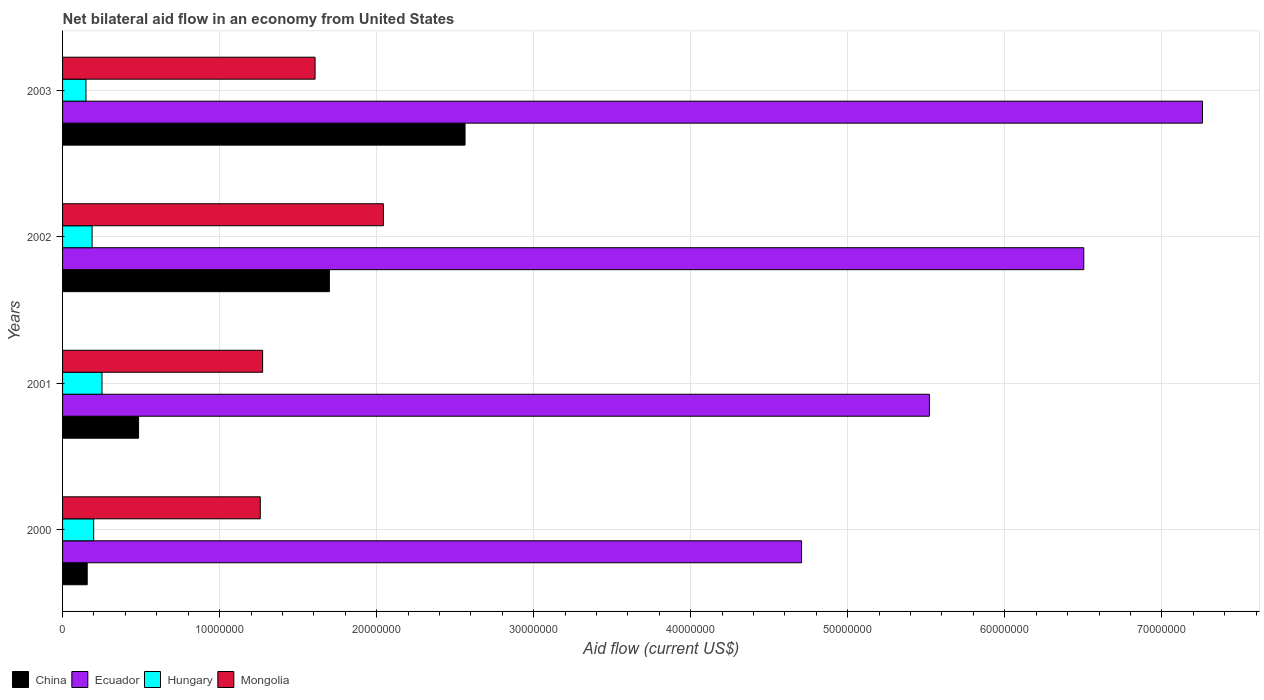How many groups of bars are there?
Make the answer very short. 4. Are the number of bars on each tick of the Y-axis equal?
Your response must be concise. Yes. How many bars are there on the 3rd tick from the top?
Ensure brevity in your answer.  4. How many bars are there on the 4th tick from the bottom?
Keep it short and to the point. 4. What is the net bilateral aid flow in China in 2003?
Give a very brief answer. 2.56e+07. Across all years, what is the maximum net bilateral aid flow in Mongolia?
Offer a very short reply. 2.04e+07. Across all years, what is the minimum net bilateral aid flow in Ecuador?
Give a very brief answer. 4.71e+07. In which year was the net bilateral aid flow in China minimum?
Provide a succinct answer. 2000. What is the total net bilateral aid flow in Hungary in the graph?
Offer a very short reply. 7.86e+06. What is the difference between the net bilateral aid flow in China in 2000 and that in 2001?
Your response must be concise. -3.27e+06. What is the difference between the net bilateral aid flow in Ecuador in 2001 and the net bilateral aid flow in Hungary in 2002?
Your answer should be very brief. 5.33e+07. What is the average net bilateral aid flow in Ecuador per year?
Provide a succinct answer. 6.00e+07. In the year 2001, what is the difference between the net bilateral aid flow in Hungary and net bilateral aid flow in China?
Your answer should be very brief. -2.33e+06. What is the ratio of the net bilateral aid flow in Ecuador in 2001 to that in 2003?
Keep it short and to the point. 0.76. What is the difference between the highest and the second highest net bilateral aid flow in China?
Provide a short and direct response. 8.64e+06. What is the difference between the highest and the lowest net bilateral aid flow in Hungary?
Provide a short and direct response. 1.02e+06. In how many years, is the net bilateral aid flow in Mongolia greater than the average net bilateral aid flow in Mongolia taken over all years?
Keep it short and to the point. 2. Is the sum of the net bilateral aid flow in Mongolia in 2002 and 2003 greater than the maximum net bilateral aid flow in Ecuador across all years?
Offer a very short reply. No. What does the 4th bar from the top in 2001 represents?
Provide a short and direct response. China. What does the 4th bar from the bottom in 2000 represents?
Your answer should be compact. Mongolia. Is it the case that in every year, the sum of the net bilateral aid flow in Mongolia and net bilateral aid flow in Hungary is greater than the net bilateral aid flow in Ecuador?
Your answer should be compact. No. Are all the bars in the graph horizontal?
Ensure brevity in your answer.  Yes. Does the graph contain any zero values?
Provide a short and direct response. No. Where does the legend appear in the graph?
Keep it short and to the point. Bottom left. How many legend labels are there?
Keep it short and to the point. 4. How are the legend labels stacked?
Make the answer very short. Horizontal. What is the title of the graph?
Offer a terse response. Net bilateral aid flow in an economy from United States. What is the label or title of the Y-axis?
Offer a terse response. Years. What is the Aid flow (current US$) in China in 2000?
Offer a very short reply. 1.57e+06. What is the Aid flow (current US$) of Ecuador in 2000?
Keep it short and to the point. 4.71e+07. What is the Aid flow (current US$) of Hungary in 2000?
Give a very brief answer. 1.98e+06. What is the Aid flow (current US$) of Mongolia in 2000?
Offer a very short reply. 1.26e+07. What is the Aid flow (current US$) of China in 2001?
Ensure brevity in your answer.  4.84e+06. What is the Aid flow (current US$) of Ecuador in 2001?
Your answer should be compact. 5.52e+07. What is the Aid flow (current US$) of Hungary in 2001?
Offer a very short reply. 2.51e+06. What is the Aid flow (current US$) in Mongolia in 2001?
Keep it short and to the point. 1.27e+07. What is the Aid flow (current US$) in China in 2002?
Your response must be concise. 1.70e+07. What is the Aid flow (current US$) of Ecuador in 2002?
Your answer should be very brief. 6.50e+07. What is the Aid flow (current US$) in Hungary in 2002?
Provide a short and direct response. 1.88e+06. What is the Aid flow (current US$) in Mongolia in 2002?
Your answer should be very brief. 2.04e+07. What is the Aid flow (current US$) in China in 2003?
Offer a terse response. 2.56e+07. What is the Aid flow (current US$) of Ecuador in 2003?
Keep it short and to the point. 7.26e+07. What is the Aid flow (current US$) in Hungary in 2003?
Ensure brevity in your answer.  1.49e+06. What is the Aid flow (current US$) of Mongolia in 2003?
Your answer should be very brief. 1.61e+07. Across all years, what is the maximum Aid flow (current US$) in China?
Your answer should be very brief. 2.56e+07. Across all years, what is the maximum Aid flow (current US$) of Ecuador?
Keep it short and to the point. 7.26e+07. Across all years, what is the maximum Aid flow (current US$) in Hungary?
Offer a terse response. 2.51e+06. Across all years, what is the maximum Aid flow (current US$) in Mongolia?
Offer a terse response. 2.04e+07. Across all years, what is the minimum Aid flow (current US$) in China?
Provide a short and direct response. 1.57e+06. Across all years, what is the minimum Aid flow (current US$) in Ecuador?
Provide a succinct answer. 4.71e+07. Across all years, what is the minimum Aid flow (current US$) of Hungary?
Provide a succinct answer. 1.49e+06. Across all years, what is the minimum Aid flow (current US$) in Mongolia?
Offer a terse response. 1.26e+07. What is the total Aid flow (current US$) of China in the graph?
Your answer should be compact. 4.90e+07. What is the total Aid flow (current US$) of Ecuador in the graph?
Offer a very short reply. 2.40e+08. What is the total Aid flow (current US$) in Hungary in the graph?
Ensure brevity in your answer.  7.86e+06. What is the total Aid flow (current US$) of Mongolia in the graph?
Offer a very short reply. 6.18e+07. What is the difference between the Aid flow (current US$) in China in 2000 and that in 2001?
Make the answer very short. -3.27e+06. What is the difference between the Aid flow (current US$) of Ecuador in 2000 and that in 2001?
Give a very brief answer. -8.14e+06. What is the difference between the Aid flow (current US$) of Hungary in 2000 and that in 2001?
Provide a succinct answer. -5.30e+05. What is the difference between the Aid flow (current US$) in China in 2000 and that in 2002?
Provide a short and direct response. -1.54e+07. What is the difference between the Aid flow (current US$) of Ecuador in 2000 and that in 2002?
Offer a terse response. -1.80e+07. What is the difference between the Aid flow (current US$) in Hungary in 2000 and that in 2002?
Your answer should be very brief. 1.00e+05. What is the difference between the Aid flow (current US$) of Mongolia in 2000 and that in 2002?
Offer a very short reply. -7.84e+06. What is the difference between the Aid flow (current US$) of China in 2000 and that in 2003?
Provide a short and direct response. -2.41e+07. What is the difference between the Aid flow (current US$) in Ecuador in 2000 and that in 2003?
Offer a terse response. -2.55e+07. What is the difference between the Aid flow (current US$) of Hungary in 2000 and that in 2003?
Give a very brief answer. 4.90e+05. What is the difference between the Aid flow (current US$) of Mongolia in 2000 and that in 2003?
Give a very brief answer. -3.49e+06. What is the difference between the Aid flow (current US$) of China in 2001 and that in 2002?
Your response must be concise. -1.22e+07. What is the difference between the Aid flow (current US$) in Ecuador in 2001 and that in 2002?
Your answer should be very brief. -9.83e+06. What is the difference between the Aid flow (current US$) of Hungary in 2001 and that in 2002?
Make the answer very short. 6.30e+05. What is the difference between the Aid flow (current US$) in Mongolia in 2001 and that in 2002?
Ensure brevity in your answer.  -7.69e+06. What is the difference between the Aid flow (current US$) of China in 2001 and that in 2003?
Your answer should be very brief. -2.08e+07. What is the difference between the Aid flow (current US$) in Ecuador in 2001 and that in 2003?
Provide a succinct answer. -1.74e+07. What is the difference between the Aid flow (current US$) in Hungary in 2001 and that in 2003?
Provide a short and direct response. 1.02e+06. What is the difference between the Aid flow (current US$) in Mongolia in 2001 and that in 2003?
Offer a very short reply. -3.34e+06. What is the difference between the Aid flow (current US$) in China in 2002 and that in 2003?
Your answer should be compact. -8.64e+06. What is the difference between the Aid flow (current US$) in Ecuador in 2002 and that in 2003?
Make the answer very short. -7.56e+06. What is the difference between the Aid flow (current US$) of Hungary in 2002 and that in 2003?
Offer a very short reply. 3.90e+05. What is the difference between the Aid flow (current US$) of Mongolia in 2002 and that in 2003?
Ensure brevity in your answer.  4.35e+06. What is the difference between the Aid flow (current US$) of China in 2000 and the Aid flow (current US$) of Ecuador in 2001?
Provide a succinct answer. -5.36e+07. What is the difference between the Aid flow (current US$) in China in 2000 and the Aid flow (current US$) in Hungary in 2001?
Your answer should be compact. -9.40e+05. What is the difference between the Aid flow (current US$) in China in 2000 and the Aid flow (current US$) in Mongolia in 2001?
Keep it short and to the point. -1.12e+07. What is the difference between the Aid flow (current US$) in Ecuador in 2000 and the Aid flow (current US$) in Hungary in 2001?
Your answer should be very brief. 4.46e+07. What is the difference between the Aid flow (current US$) of Ecuador in 2000 and the Aid flow (current US$) of Mongolia in 2001?
Offer a terse response. 3.43e+07. What is the difference between the Aid flow (current US$) in Hungary in 2000 and the Aid flow (current US$) in Mongolia in 2001?
Your answer should be very brief. -1.08e+07. What is the difference between the Aid flow (current US$) in China in 2000 and the Aid flow (current US$) in Ecuador in 2002?
Keep it short and to the point. -6.35e+07. What is the difference between the Aid flow (current US$) of China in 2000 and the Aid flow (current US$) of Hungary in 2002?
Provide a succinct answer. -3.10e+05. What is the difference between the Aid flow (current US$) of China in 2000 and the Aid flow (current US$) of Mongolia in 2002?
Offer a very short reply. -1.89e+07. What is the difference between the Aid flow (current US$) in Ecuador in 2000 and the Aid flow (current US$) in Hungary in 2002?
Your answer should be compact. 4.52e+07. What is the difference between the Aid flow (current US$) of Ecuador in 2000 and the Aid flow (current US$) of Mongolia in 2002?
Provide a succinct answer. 2.66e+07. What is the difference between the Aid flow (current US$) in Hungary in 2000 and the Aid flow (current US$) in Mongolia in 2002?
Ensure brevity in your answer.  -1.84e+07. What is the difference between the Aid flow (current US$) in China in 2000 and the Aid flow (current US$) in Ecuador in 2003?
Offer a very short reply. -7.10e+07. What is the difference between the Aid flow (current US$) in China in 2000 and the Aid flow (current US$) in Hungary in 2003?
Ensure brevity in your answer.  8.00e+04. What is the difference between the Aid flow (current US$) in China in 2000 and the Aid flow (current US$) in Mongolia in 2003?
Give a very brief answer. -1.45e+07. What is the difference between the Aid flow (current US$) in Ecuador in 2000 and the Aid flow (current US$) in Hungary in 2003?
Offer a terse response. 4.56e+07. What is the difference between the Aid flow (current US$) of Ecuador in 2000 and the Aid flow (current US$) of Mongolia in 2003?
Offer a very short reply. 3.10e+07. What is the difference between the Aid flow (current US$) in Hungary in 2000 and the Aid flow (current US$) in Mongolia in 2003?
Your response must be concise. -1.41e+07. What is the difference between the Aid flow (current US$) in China in 2001 and the Aid flow (current US$) in Ecuador in 2002?
Offer a very short reply. -6.02e+07. What is the difference between the Aid flow (current US$) in China in 2001 and the Aid flow (current US$) in Hungary in 2002?
Give a very brief answer. 2.96e+06. What is the difference between the Aid flow (current US$) in China in 2001 and the Aid flow (current US$) in Mongolia in 2002?
Your answer should be compact. -1.56e+07. What is the difference between the Aid flow (current US$) of Ecuador in 2001 and the Aid flow (current US$) of Hungary in 2002?
Your response must be concise. 5.33e+07. What is the difference between the Aid flow (current US$) in Ecuador in 2001 and the Aid flow (current US$) in Mongolia in 2002?
Offer a terse response. 3.48e+07. What is the difference between the Aid flow (current US$) of Hungary in 2001 and the Aid flow (current US$) of Mongolia in 2002?
Offer a terse response. -1.79e+07. What is the difference between the Aid flow (current US$) of China in 2001 and the Aid flow (current US$) of Ecuador in 2003?
Provide a short and direct response. -6.78e+07. What is the difference between the Aid flow (current US$) in China in 2001 and the Aid flow (current US$) in Hungary in 2003?
Your answer should be compact. 3.35e+06. What is the difference between the Aid flow (current US$) of China in 2001 and the Aid flow (current US$) of Mongolia in 2003?
Your answer should be very brief. -1.12e+07. What is the difference between the Aid flow (current US$) of Ecuador in 2001 and the Aid flow (current US$) of Hungary in 2003?
Your response must be concise. 5.37e+07. What is the difference between the Aid flow (current US$) of Ecuador in 2001 and the Aid flow (current US$) of Mongolia in 2003?
Give a very brief answer. 3.91e+07. What is the difference between the Aid flow (current US$) of Hungary in 2001 and the Aid flow (current US$) of Mongolia in 2003?
Provide a succinct answer. -1.36e+07. What is the difference between the Aid flow (current US$) of China in 2002 and the Aid flow (current US$) of Ecuador in 2003?
Offer a terse response. -5.56e+07. What is the difference between the Aid flow (current US$) of China in 2002 and the Aid flow (current US$) of Hungary in 2003?
Provide a short and direct response. 1.55e+07. What is the difference between the Aid flow (current US$) in China in 2002 and the Aid flow (current US$) in Mongolia in 2003?
Make the answer very short. 9.10e+05. What is the difference between the Aid flow (current US$) of Ecuador in 2002 and the Aid flow (current US$) of Hungary in 2003?
Your response must be concise. 6.35e+07. What is the difference between the Aid flow (current US$) in Ecuador in 2002 and the Aid flow (current US$) in Mongolia in 2003?
Your answer should be compact. 4.90e+07. What is the difference between the Aid flow (current US$) in Hungary in 2002 and the Aid flow (current US$) in Mongolia in 2003?
Provide a short and direct response. -1.42e+07. What is the average Aid flow (current US$) in China per year?
Your answer should be very brief. 1.23e+07. What is the average Aid flow (current US$) of Ecuador per year?
Your answer should be very brief. 6.00e+07. What is the average Aid flow (current US$) of Hungary per year?
Your answer should be very brief. 1.96e+06. What is the average Aid flow (current US$) of Mongolia per year?
Give a very brief answer. 1.55e+07. In the year 2000, what is the difference between the Aid flow (current US$) of China and Aid flow (current US$) of Ecuador?
Keep it short and to the point. -4.55e+07. In the year 2000, what is the difference between the Aid flow (current US$) in China and Aid flow (current US$) in Hungary?
Provide a succinct answer. -4.10e+05. In the year 2000, what is the difference between the Aid flow (current US$) of China and Aid flow (current US$) of Mongolia?
Make the answer very short. -1.10e+07. In the year 2000, what is the difference between the Aid flow (current US$) in Ecuador and Aid flow (current US$) in Hungary?
Give a very brief answer. 4.51e+07. In the year 2000, what is the difference between the Aid flow (current US$) of Ecuador and Aid flow (current US$) of Mongolia?
Your response must be concise. 3.45e+07. In the year 2000, what is the difference between the Aid flow (current US$) in Hungary and Aid flow (current US$) in Mongolia?
Offer a terse response. -1.06e+07. In the year 2001, what is the difference between the Aid flow (current US$) of China and Aid flow (current US$) of Ecuador?
Provide a short and direct response. -5.04e+07. In the year 2001, what is the difference between the Aid flow (current US$) in China and Aid flow (current US$) in Hungary?
Your response must be concise. 2.33e+06. In the year 2001, what is the difference between the Aid flow (current US$) in China and Aid flow (current US$) in Mongolia?
Make the answer very short. -7.90e+06. In the year 2001, what is the difference between the Aid flow (current US$) of Ecuador and Aid flow (current US$) of Hungary?
Provide a succinct answer. 5.27e+07. In the year 2001, what is the difference between the Aid flow (current US$) in Ecuador and Aid flow (current US$) in Mongolia?
Offer a terse response. 4.25e+07. In the year 2001, what is the difference between the Aid flow (current US$) in Hungary and Aid flow (current US$) in Mongolia?
Keep it short and to the point. -1.02e+07. In the year 2002, what is the difference between the Aid flow (current US$) in China and Aid flow (current US$) in Ecuador?
Provide a short and direct response. -4.80e+07. In the year 2002, what is the difference between the Aid flow (current US$) in China and Aid flow (current US$) in Hungary?
Provide a succinct answer. 1.51e+07. In the year 2002, what is the difference between the Aid flow (current US$) in China and Aid flow (current US$) in Mongolia?
Provide a succinct answer. -3.44e+06. In the year 2002, what is the difference between the Aid flow (current US$) in Ecuador and Aid flow (current US$) in Hungary?
Your answer should be compact. 6.32e+07. In the year 2002, what is the difference between the Aid flow (current US$) in Ecuador and Aid flow (current US$) in Mongolia?
Give a very brief answer. 4.46e+07. In the year 2002, what is the difference between the Aid flow (current US$) in Hungary and Aid flow (current US$) in Mongolia?
Offer a terse response. -1.86e+07. In the year 2003, what is the difference between the Aid flow (current US$) of China and Aid flow (current US$) of Ecuador?
Give a very brief answer. -4.70e+07. In the year 2003, what is the difference between the Aid flow (current US$) in China and Aid flow (current US$) in Hungary?
Give a very brief answer. 2.41e+07. In the year 2003, what is the difference between the Aid flow (current US$) of China and Aid flow (current US$) of Mongolia?
Provide a succinct answer. 9.55e+06. In the year 2003, what is the difference between the Aid flow (current US$) in Ecuador and Aid flow (current US$) in Hungary?
Your response must be concise. 7.11e+07. In the year 2003, what is the difference between the Aid flow (current US$) in Ecuador and Aid flow (current US$) in Mongolia?
Provide a short and direct response. 5.65e+07. In the year 2003, what is the difference between the Aid flow (current US$) in Hungary and Aid flow (current US$) in Mongolia?
Provide a short and direct response. -1.46e+07. What is the ratio of the Aid flow (current US$) of China in 2000 to that in 2001?
Make the answer very short. 0.32. What is the ratio of the Aid flow (current US$) in Ecuador in 2000 to that in 2001?
Provide a short and direct response. 0.85. What is the ratio of the Aid flow (current US$) of Hungary in 2000 to that in 2001?
Your response must be concise. 0.79. What is the ratio of the Aid flow (current US$) in Mongolia in 2000 to that in 2001?
Your answer should be compact. 0.99. What is the ratio of the Aid flow (current US$) of China in 2000 to that in 2002?
Provide a succinct answer. 0.09. What is the ratio of the Aid flow (current US$) in Ecuador in 2000 to that in 2002?
Ensure brevity in your answer.  0.72. What is the ratio of the Aid flow (current US$) in Hungary in 2000 to that in 2002?
Ensure brevity in your answer.  1.05. What is the ratio of the Aid flow (current US$) of Mongolia in 2000 to that in 2002?
Your response must be concise. 0.62. What is the ratio of the Aid flow (current US$) in China in 2000 to that in 2003?
Your response must be concise. 0.06. What is the ratio of the Aid flow (current US$) of Ecuador in 2000 to that in 2003?
Provide a short and direct response. 0.65. What is the ratio of the Aid flow (current US$) in Hungary in 2000 to that in 2003?
Ensure brevity in your answer.  1.33. What is the ratio of the Aid flow (current US$) in Mongolia in 2000 to that in 2003?
Ensure brevity in your answer.  0.78. What is the ratio of the Aid flow (current US$) in China in 2001 to that in 2002?
Provide a succinct answer. 0.28. What is the ratio of the Aid flow (current US$) in Ecuador in 2001 to that in 2002?
Offer a very short reply. 0.85. What is the ratio of the Aid flow (current US$) in Hungary in 2001 to that in 2002?
Provide a succinct answer. 1.34. What is the ratio of the Aid flow (current US$) of Mongolia in 2001 to that in 2002?
Your response must be concise. 0.62. What is the ratio of the Aid flow (current US$) in China in 2001 to that in 2003?
Make the answer very short. 0.19. What is the ratio of the Aid flow (current US$) of Ecuador in 2001 to that in 2003?
Offer a terse response. 0.76. What is the ratio of the Aid flow (current US$) of Hungary in 2001 to that in 2003?
Ensure brevity in your answer.  1.68. What is the ratio of the Aid flow (current US$) of Mongolia in 2001 to that in 2003?
Give a very brief answer. 0.79. What is the ratio of the Aid flow (current US$) of China in 2002 to that in 2003?
Ensure brevity in your answer.  0.66. What is the ratio of the Aid flow (current US$) of Ecuador in 2002 to that in 2003?
Give a very brief answer. 0.9. What is the ratio of the Aid flow (current US$) in Hungary in 2002 to that in 2003?
Ensure brevity in your answer.  1.26. What is the ratio of the Aid flow (current US$) in Mongolia in 2002 to that in 2003?
Ensure brevity in your answer.  1.27. What is the difference between the highest and the second highest Aid flow (current US$) of China?
Give a very brief answer. 8.64e+06. What is the difference between the highest and the second highest Aid flow (current US$) of Ecuador?
Keep it short and to the point. 7.56e+06. What is the difference between the highest and the second highest Aid flow (current US$) in Hungary?
Keep it short and to the point. 5.30e+05. What is the difference between the highest and the second highest Aid flow (current US$) in Mongolia?
Offer a very short reply. 4.35e+06. What is the difference between the highest and the lowest Aid flow (current US$) in China?
Keep it short and to the point. 2.41e+07. What is the difference between the highest and the lowest Aid flow (current US$) in Ecuador?
Make the answer very short. 2.55e+07. What is the difference between the highest and the lowest Aid flow (current US$) in Hungary?
Provide a short and direct response. 1.02e+06. What is the difference between the highest and the lowest Aid flow (current US$) of Mongolia?
Your answer should be compact. 7.84e+06. 